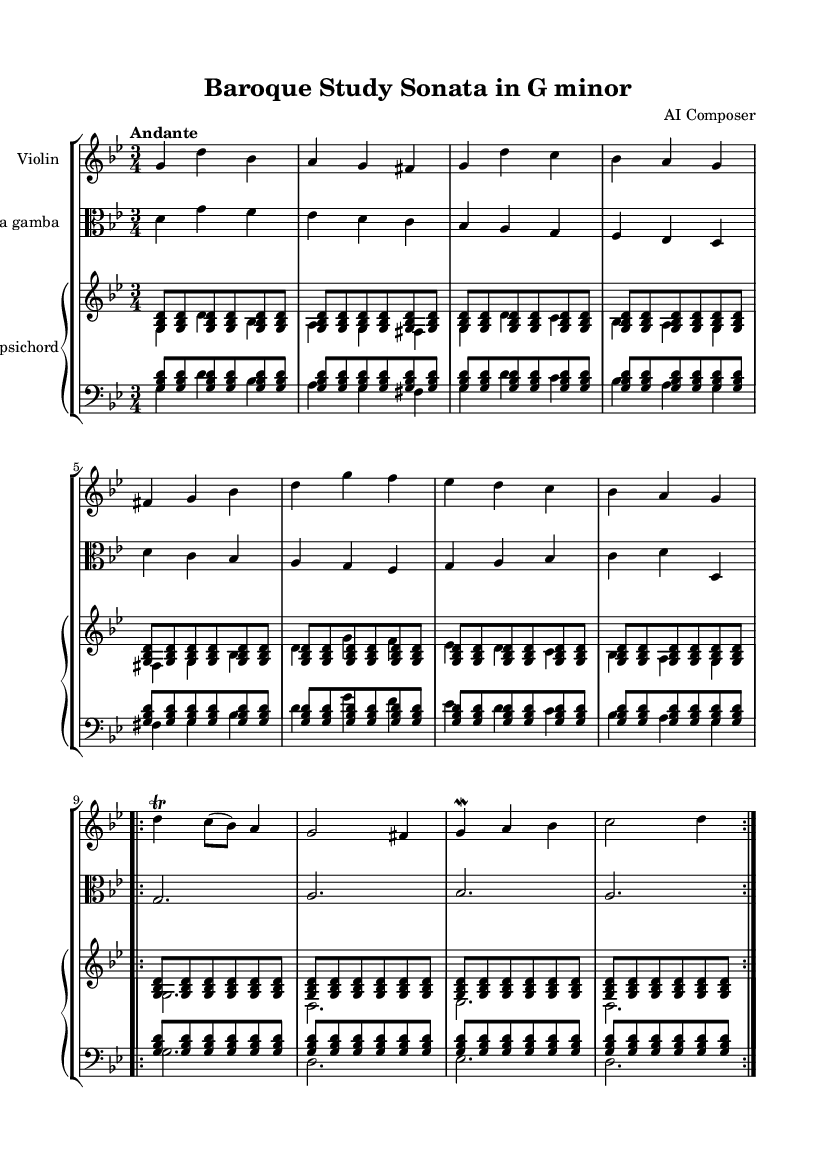What is the key signature of this music? The key signature is G minor, indicated by two flats (B♭ and E♭). This can be determined by examining the key signature at the beginning of the staff.
Answer: G minor What is the time signature of this piece? The time signature is 3/4, as shown at the beginning of the score. This implies that there are three beats in each measure.
Answer: 3/4 What is the tempo marking for this sonata? The tempo marking is "Andante," which indicates a moderately slow tempo. This is found directly above the staff in the score.
Answer: Andante How many measures are repeated in the violin part? There are 2 measures repeated in the violin part, indicated by the "volta" marking. This shows the performer to repeat the section instead of moving on.
Answer: 2 What instruments are included in this piece? The instruments included are violin, viola da gamba, and harpsichord. This can be found in the header and the staff group labels.
Answer: Violin, viola da gamba, harpsichord What does the "trill" indicate in the violin part? The "trill" symbol indicates that the player should rapidly alternate between the written note (D) and the note directly above it (E♭). This ornamentation is commonly used in Baroque music to embellish a melody.
Answer: Rapid note alternation What is the role of the harpsichord in this piece? The harpsichord serves as both a harmonic and rhythmic support, providing a continuo part. This is evident from the two staff arrangement, with the upper staff playing chords and the lower staff playing bass notes.
Answer: Harmonic and rhythmic support 